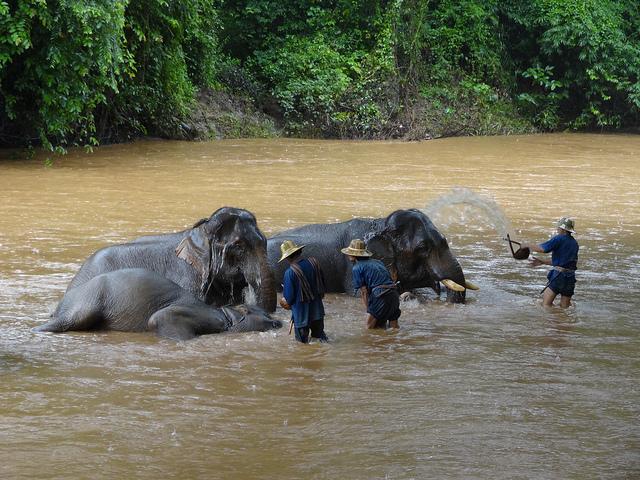Are these elephants sad?
Keep it brief. No. What animal is this?
Short answer required. Elephant. How many trunks are on the elephants?
Quick response, please. 2. Does this water look clear?
Answer briefly. No. 